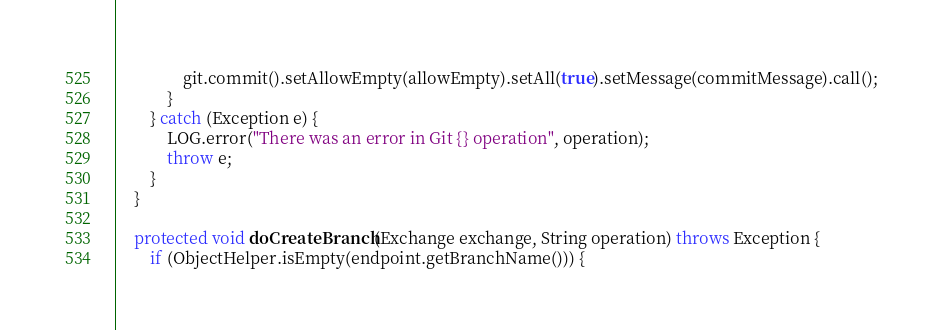<code> <loc_0><loc_0><loc_500><loc_500><_Java_>                git.commit().setAllowEmpty(allowEmpty).setAll(true).setMessage(commitMessage).call();
            }
        } catch (Exception e) {
            LOG.error("There was an error in Git {} operation", operation);
            throw e;
        }
    }

    protected void doCreateBranch(Exchange exchange, String operation) throws Exception {
        if (ObjectHelper.isEmpty(endpoint.getBranchName())) {</code> 